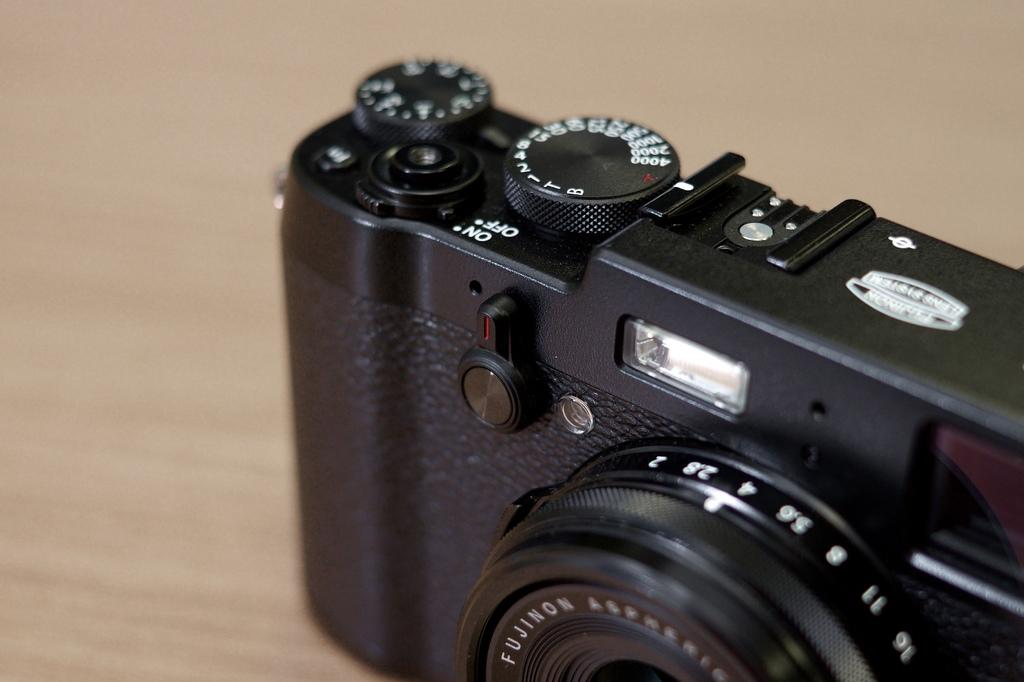<image>
Offer a succinct explanation of the picture presented. A black camera made by the company FUJINON. 